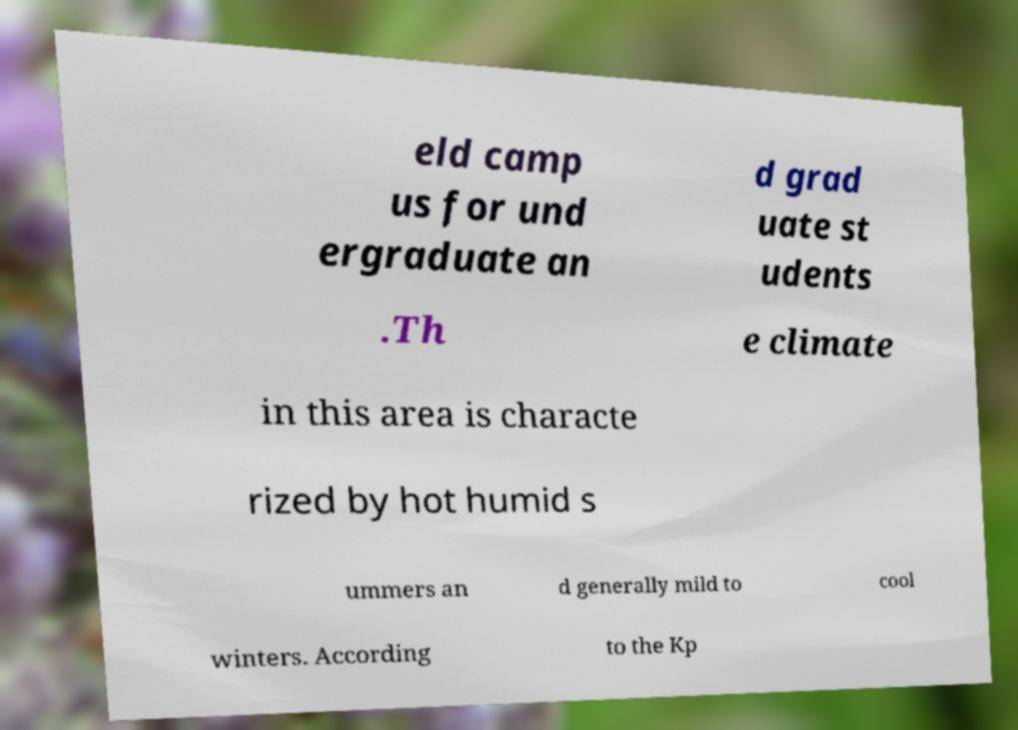Please read and relay the text visible in this image. What does it say? eld camp us for und ergraduate an d grad uate st udents .Th e climate in this area is characte rized by hot humid s ummers an d generally mild to cool winters. According to the Kp 